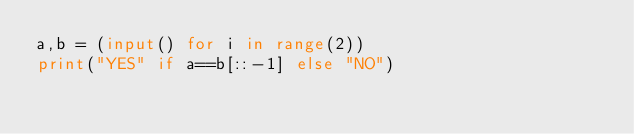Convert code to text. <code><loc_0><loc_0><loc_500><loc_500><_Python_>a,b = (input() for i in range(2))
print("YES" if a==b[::-1] else "NO")
</code> 